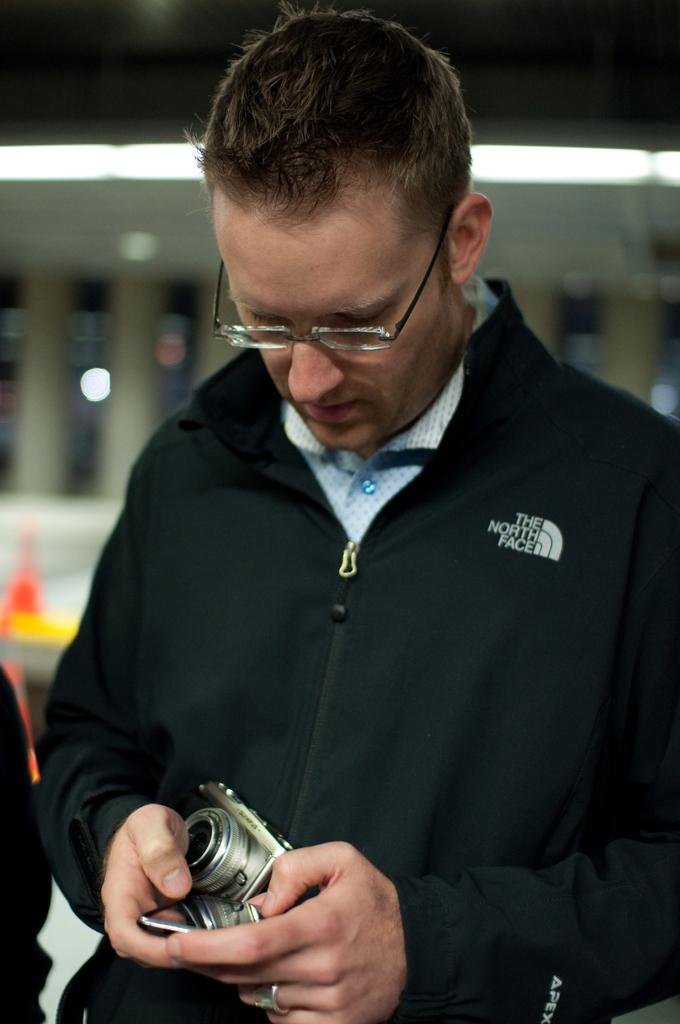Who is the main subject in the image? There is a man in the image. What is the man wearing that helps him see better? The man is wearing glasses (specs) in the image. What is the man holding in his hands? The man is holding a camera and a mobile in the image. Can you describe the background of the image? The background of the image is blurry. What type of cream can be seen on the branch in the image? There is no cream or branch present in the image. How many berries are visible on the man's hat in the image? There is no hat or berries present in the image. 